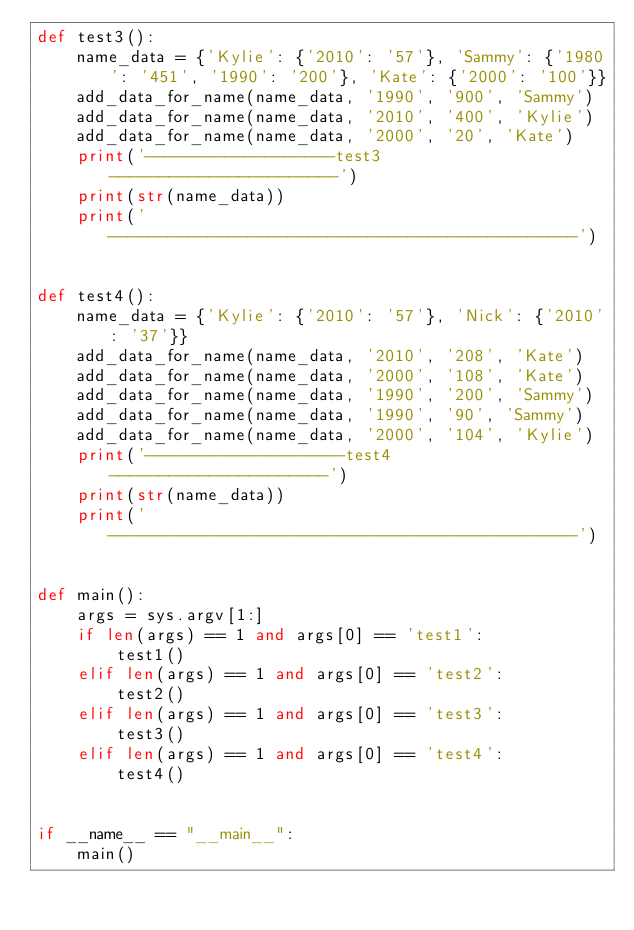Convert code to text. <code><loc_0><loc_0><loc_500><loc_500><_Python_>def test3():
    name_data = {'Kylie': {'2010': '57'}, 'Sammy': {'1980': '451', '1990': '200'}, 'Kate': {'2000': '100'}}
    add_data_for_name(name_data, '1990', '900', 'Sammy')
    add_data_for_name(name_data, '2010', '400', 'Kylie')
    add_data_for_name(name_data, '2000', '20', 'Kate')
    print('-------------------test3-----------------------')
    print(str(name_data))
    print('-----------------------------------------------')


def test4():
    name_data = {'Kylie': {'2010': '57'}, 'Nick': {'2010': '37'}}
    add_data_for_name(name_data, '2010', '208', 'Kate')
    add_data_for_name(name_data, '2000', '108', 'Kate')
    add_data_for_name(name_data, '1990', '200', 'Sammy')
    add_data_for_name(name_data, '1990', '90', 'Sammy')
    add_data_for_name(name_data, '2000', '104', 'Kylie')
    print('--------------------test4----------------------')
    print(str(name_data))
    print('-----------------------------------------------')


def main():
    args = sys.argv[1:]
    if len(args) == 1 and args[0] == 'test1':
        test1()
    elif len(args) == 1 and args[0] == 'test2':
        test2()
    elif len(args) == 1 and args[0] == 'test3':
        test3()
    elif len(args) == 1 and args[0] == 'test4':
        test4()


if __name__ == "__main__":
    main()
</code> 